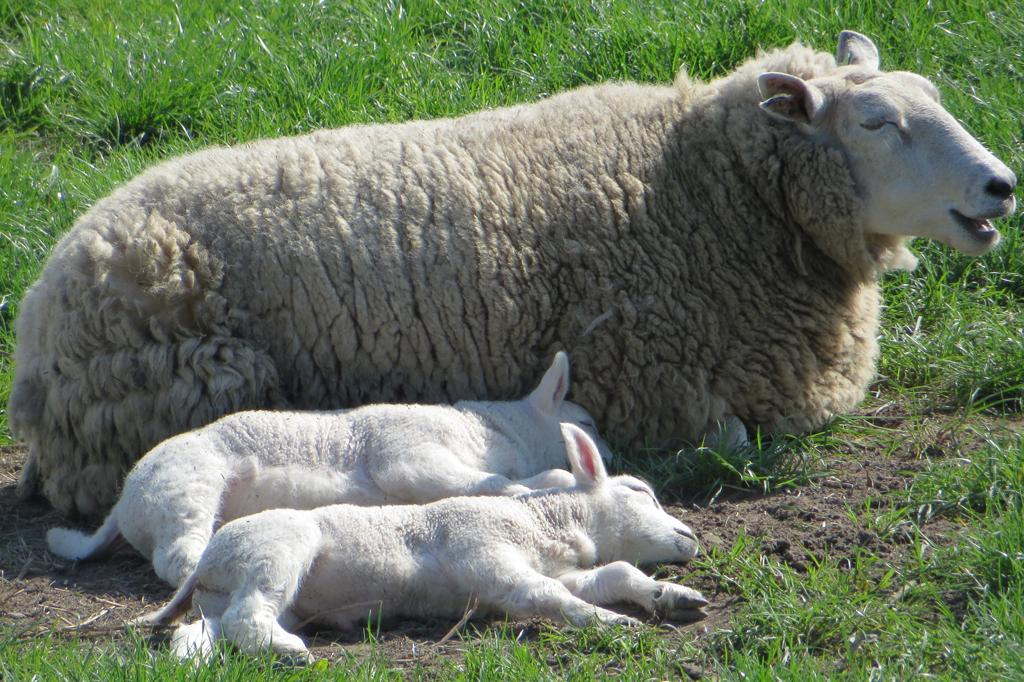What types of living organisms can be seen in the image? There are animals in the image. What type of vegetation is visible in the image? There is grass in the image. What is the relation between the animals and the grass in the image? There is no specific relation between the animals and the grass mentioned in the image. The animals may be interacting with the grass, but we cannot determine that from the given facts. 